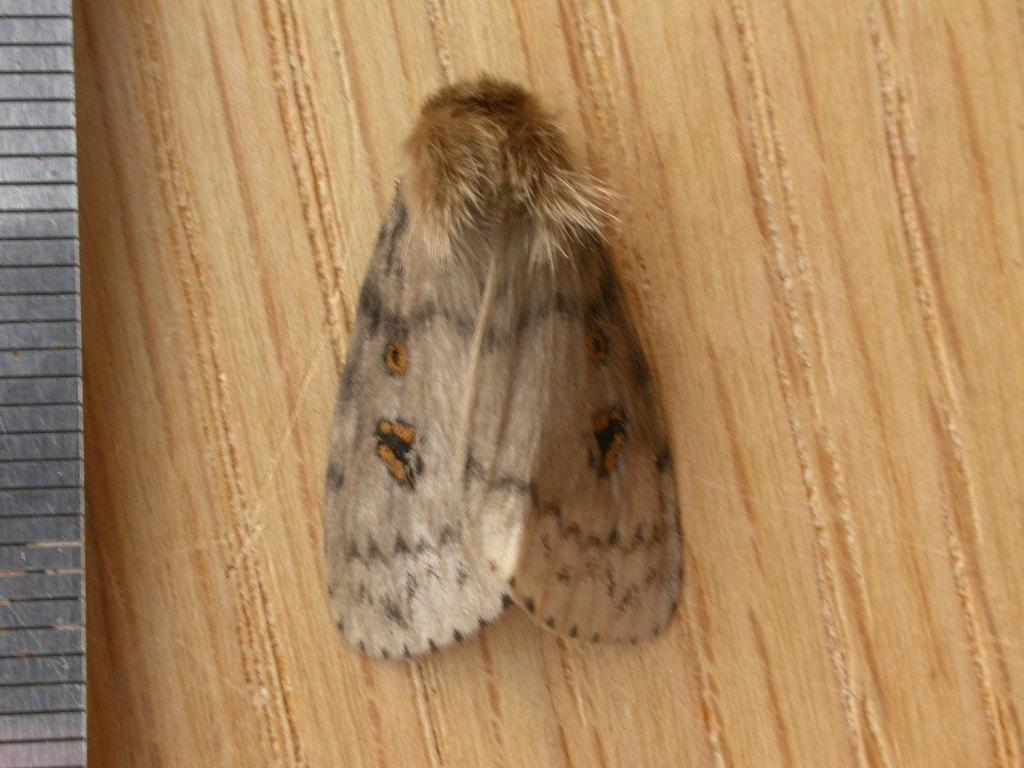What is the main subject in the foreground of the image? There is an insect in the foreground of the image. Can you describe the setting of the image? The image may have been taken in a room. How many bells are hanging from the insect in the image? There are no bells present in the image, as it features an insect in the foreground. 